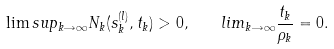<formula> <loc_0><loc_0><loc_500><loc_500>\lim s u p _ { k \rightarrow \infty } N _ { k } ( s _ { k } ^ { ( l ) } , t _ { k } ) > 0 , \ \ \ l i m _ { k \rightarrow \infty } \frac { t _ { k } } { \rho _ { k } } = 0 .</formula> 